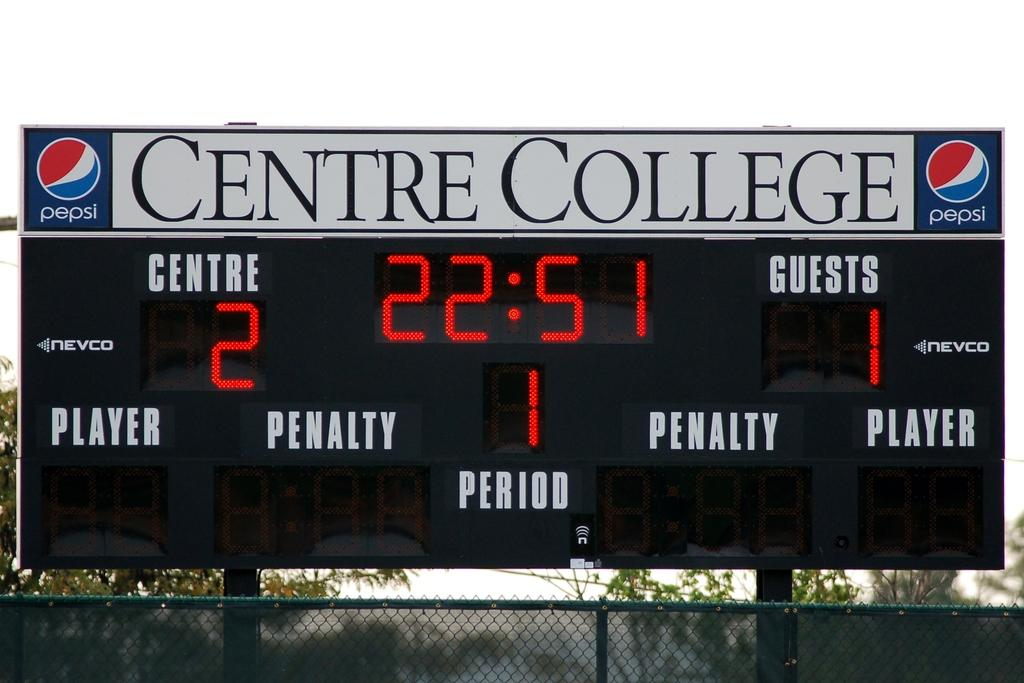<image>
Provide a brief description of the given image. A scoreboard of a college sport game held at Centre College. 